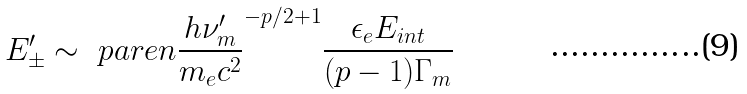<formula> <loc_0><loc_0><loc_500><loc_500>E ^ { \prime } _ { \pm } \sim \ p a r e n { \frac { h \nu ^ { \prime } _ { m } } { m _ { e } c ^ { 2 } } } ^ { - p / 2 + 1 } \frac { \epsilon _ { e } E _ { i n t } } { ( p - 1 ) \Gamma _ { m } }</formula> 